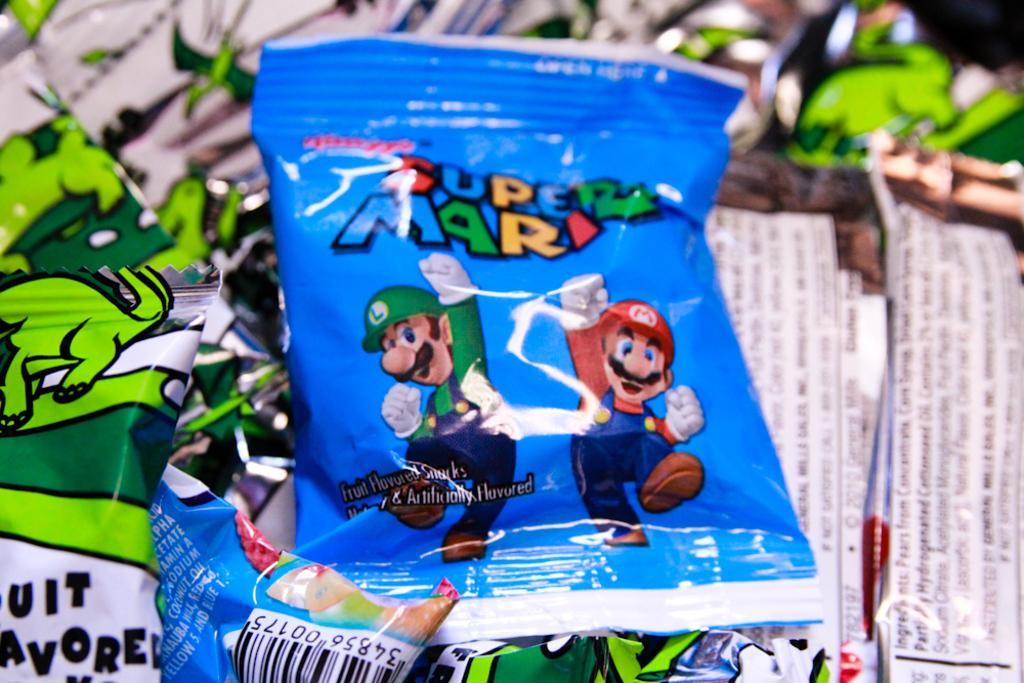Can you describe this image briefly? There are few packets which are blue and green in color. 